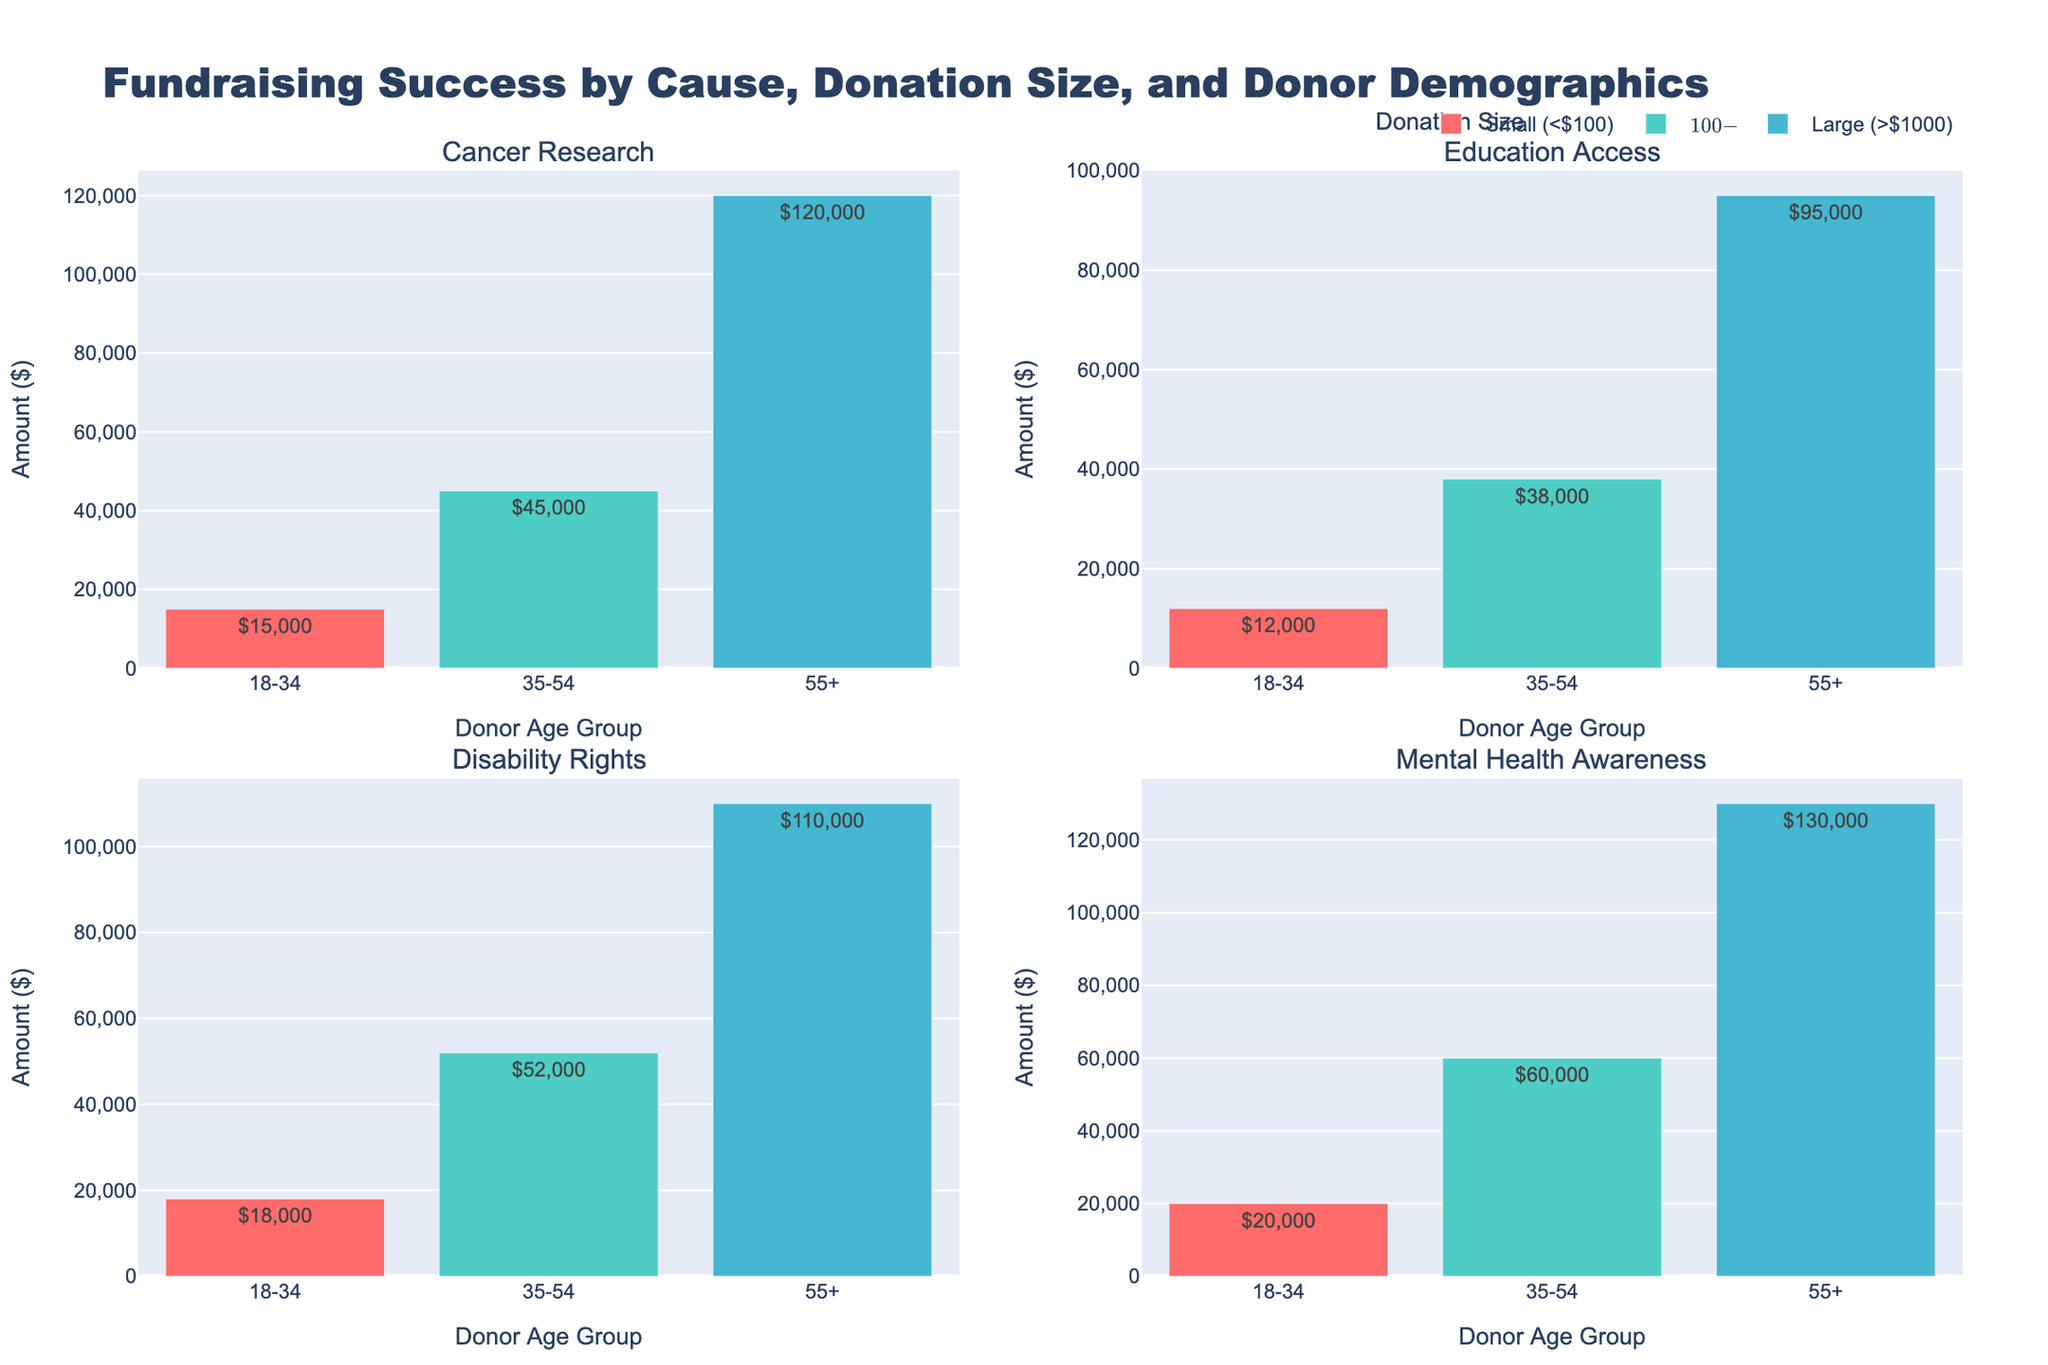What is the total amount donated to Cancer Research by donors aged 55+? Find the bar representing Cancer Research, look at the 55+ age group for the amount donated, it's a large donation size.
Answer: $120,000 Which donor age group contributed the most to Mental Health Awareness? Identify the bar for Mental Health Awareness, then compare the amounts for each age group. The 55+ age group, donating in the large size category, has the highest value.
Answer: 55+ How does the amount donated to Disability Rights by female donors compare between the small and large donation sizes? Look at the bars for Disability Rights, specifically for female donors in both the small (< $100) and large (> $1000) donation sizes. The amounts are $18,000 for small and $110,000 for large. Comparing these, $110,000 is much greater than $18,000.
Answer: Female donors give more in the large category What is the average donation amount for Education Access for the medium and large donation sizes? Sum the donation amounts for medium ($100-$1000) and large (> $1000) categories for Education Access, which are $38,000 and $95,000 respectively, then divide by 2. ($38,000 + $95,000)/2 = $66,500
Answer: $66,500 Which cause received the highest total amount from medium-sized donations? For each cause, find the bar related to medium-sized donations ($100-$1000), then compare the donation amounts across Cancer Research, Education Access, Disability Rights, and Mental Health Awareness. Mental Health Awareness received $60,000, which is the highest.
Answer: Mental Health Awareness Compare the total donations by male and female donors for Cancer Research. Add up the amounts donated by males and females for Cancer Research: Males (medium) donated $45,000 and females (small and large) donated $15,000 + $120,000. So, males = $45,000 and females = $135,000. Females donated more.
Answer: Females donated more What percentage of the total large donations does Mental Health Awareness receive from male donors? Identify the large donations for all causes and their amounts from male donors. The amounts given by male donors in the large category are Cancer Research ($0), Education Access ($95,000), Disability Rights ($0), and Mental Health Awareness ($130,000). Total large donations are $225,000. Therefore, percentage = ($130,000/$225,000) * 100 = 57.8%
Answer: 57.8% What is the difference in total donations between large and small donation sizes for Cancer Research? For Cancer Research, sum the donations for large (> $1000, $120,000) and small (< $100, $15,000). The difference is $120,000 - $15,000 = $105,000
Answer: $105,000 Which gender contributed the most to Disability Rights? Compare the total donation amounts for male and female donors for Disability Rights: Males (medium) contributed $52,000 and females (small and large) contributed $18,000 + $110,000. Total for males = $52,000, total for females = $128,000. Females contributed more.
Answer: Females 